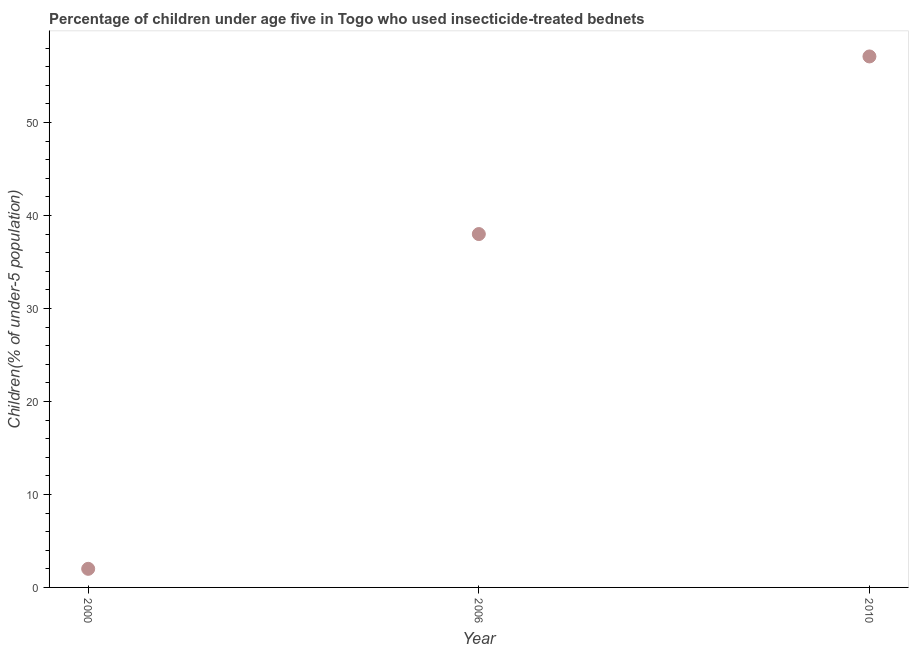What is the percentage of children who use of insecticide-treated bed nets in 2000?
Provide a succinct answer. 2. Across all years, what is the maximum percentage of children who use of insecticide-treated bed nets?
Keep it short and to the point. 57.1. In which year was the percentage of children who use of insecticide-treated bed nets maximum?
Your answer should be compact. 2010. What is the sum of the percentage of children who use of insecticide-treated bed nets?
Make the answer very short. 97.1. What is the difference between the percentage of children who use of insecticide-treated bed nets in 2006 and 2010?
Your answer should be very brief. -19.1. What is the average percentage of children who use of insecticide-treated bed nets per year?
Give a very brief answer. 32.37. What is the median percentage of children who use of insecticide-treated bed nets?
Provide a short and direct response. 38. Do a majority of the years between 2006 and 2010 (inclusive) have percentage of children who use of insecticide-treated bed nets greater than 12 %?
Your answer should be compact. Yes. What is the ratio of the percentage of children who use of insecticide-treated bed nets in 2006 to that in 2010?
Provide a succinct answer. 0.67. Is the percentage of children who use of insecticide-treated bed nets in 2000 less than that in 2010?
Provide a short and direct response. Yes. Is the difference between the percentage of children who use of insecticide-treated bed nets in 2000 and 2006 greater than the difference between any two years?
Your answer should be compact. No. Is the sum of the percentage of children who use of insecticide-treated bed nets in 2000 and 2006 greater than the maximum percentage of children who use of insecticide-treated bed nets across all years?
Your answer should be compact. No. What is the difference between the highest and the lowest percentage of children who use of insecticide-treated bed nets?
Give a very brief answer. 55.1. In how many years, is the percentage of children who use of insecticide-treated bed nets greater than the average percentage of children who use of insecticide-treated bed nets taken over all years?
Your answer should be very brief. 2. How many dotlines are there?
Give a very brief answer. 1. How many years are there in the graph?
Provide a short and direct response. 3. What is the difference between two consecutive major ticks on the Y-axis?
Make the answer very short. 10. Are the values on the major ticks of Y-axis written in scientific E-notation?
Offer a very short reply. No. Does the graph contain any zero values?
Provide a short and direct response. No. What is the title of the graph?
Ensure brevity in your answer.  Percentage of children under age five in Togo who used insecticide-treated bednets. What is the label or title of the X-axis?
Keep it short and to the point. Year. What is the label or title of the Y-axis?
Keep it short and to the point. Children(% of under-5 population). What is the Children(% of under-5 population) in 2000?
Provide a succinct answer. 2. What is the Children(% of under-5 population) in 2010?
Ensure brevity in your answer.  57.1. What is the difference between the Children(% of under-5 population) in 2000 and 2006?
Offer a terse response. -36. What is the difference between the Children(% of under-5 population) in 2000 and 2010?
Offer a terse response. -55.1. What is the difference between the Children(% of under-5 population) in 2006 and 2010?
Offer a very short reply. -19.1. What is the ratio of the Children(% of under-5 population) in 2000 to that in 2006?
Your response must be concise. 0.05. What is the ratio of the Children(% of under-5 population) in 2000 to that in 2010?
Keep it short and to the point. 0.04. What is the ratio of the Children(% of under-5 population) in 2006 to that in 2010?
Keep it short and to the point. 0.67. 